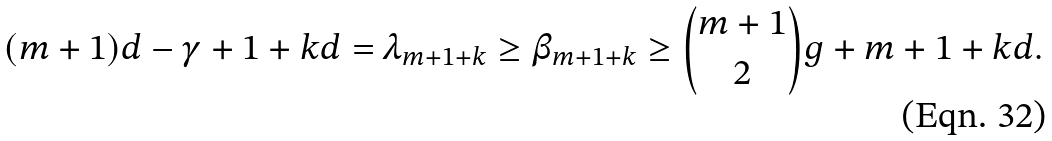Convert formula to latex. <formula><loc_0><loc_0><loc_500><loc_500>( m + 1 ) d - \gamma + 1 + k d = \lambda _ { m + 1 + k } \geq \beta _ { m + 1 + k } \geq { { m + 1 } \choose 2 } g + m + 1 + k d .</formula> 